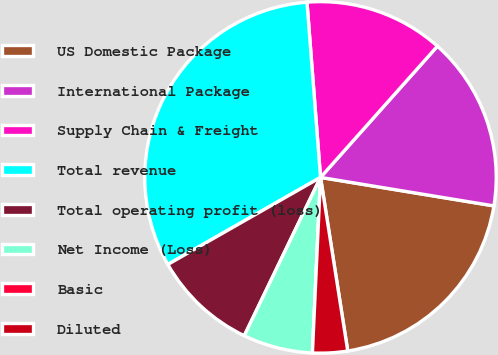Convert chart. <chart><loc_0><loc_0><loc_500><loc_500><pie_chart><fcel>US Domestic Package<fcel>International Package<fcel>Supply Chain & Freight<fcel>Total revenue<fcel>Total operating profit (loss)<fcel>Net Income (Loss)<fcel>Basic<fcel>Diluted<nl><fcel>19.93%<fcel>16.01%<fcel>12.81%<fcel>32.02%<fcel>9.61%<fcel>6.41%<fcel>0.0%<fcel>3.21%<nl></chart> 